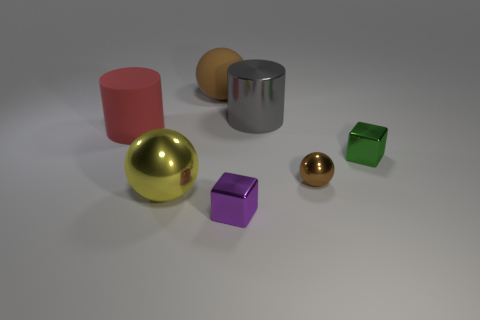If these objects were part of a game, what kind of game could it be? These objects could be part of an educational game designed for children, focusing on shape and color recognition. They could also be used in a physical puzzle game, where the goal is to place the objects in matching shaped slots based on color and shape cues. 